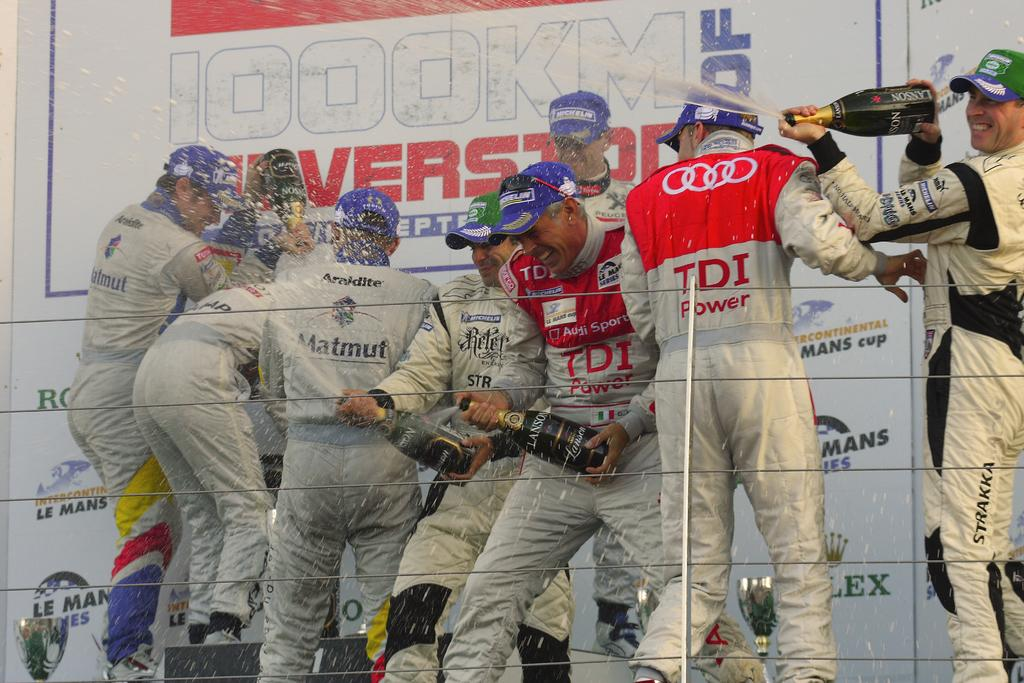Provide a one-sentence caption for the provided image. Olympic team, sponsored by TDI and Matmut, celebrating. 